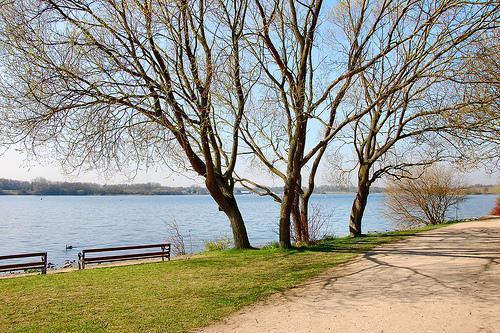How many benches are shown?
Give a very brief answer. 2. How many tall trees are shown?
Give a very brief answer. 4. 